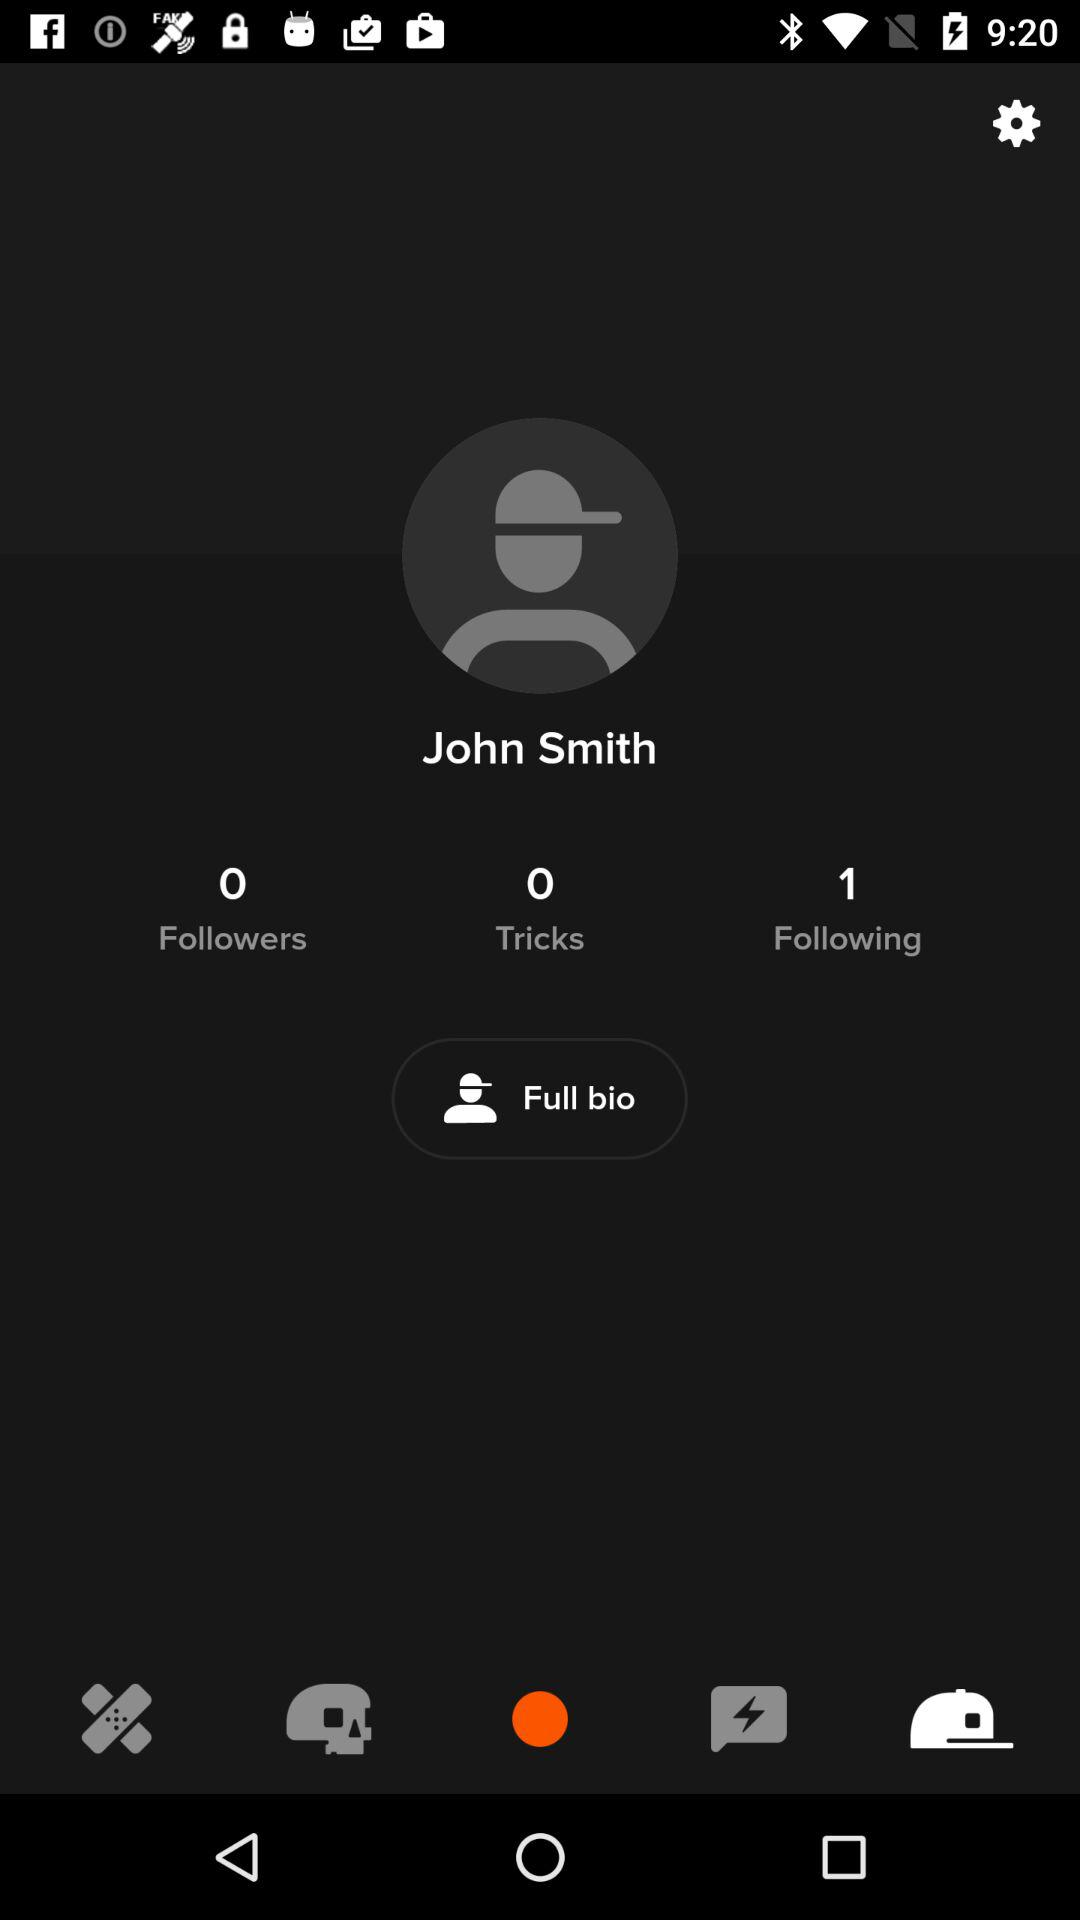How many followers are there? There are 0 followers. 